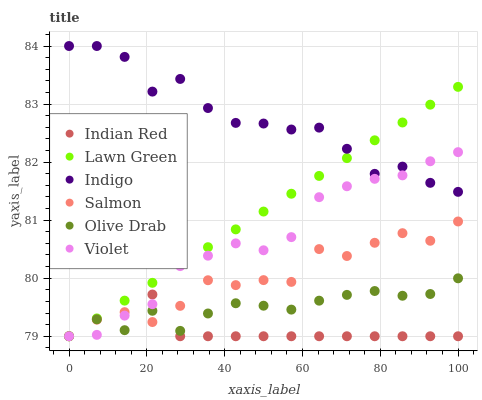Does Indian Red have the minimum area under the curve?
Answer yes or no. Yes. Does Indigo have the maximum area under the curve?
Answer yes or no. Yes. Does Salmon have the minimum area under the curve?
Answer yes or no. No. Does Salmon have the maximum area under the curve?
Answer yes or no. No. Is Lawn Green the smoothest?
Answer yes or no. Yes. Is Indigo the roughest?
Answer yes or no. Yes. Is Salmon the smoothest?
Answer yes or no. No. Is Salmon the roughest?
Answer yes or no. No. Does Lawn Green have the lowest value?
Answer yes or no. Yes. Does Indigo have the lowest value?
Answer yes or no. No. Does Indigo have the highest value?
Answer yes or no. Yes. Does Salmon have the highest value?
Answer yes or no. No. Is Olive Drab less than Indigo?
Answer yes or no. Yes. Is Indigo greater than Salmon?
Answer yes or no. Yes. Does Salmon intersect Indian Red?
Answer yes or no. Yes. Is Salmon less than Indian Red?
Answer yes or no. No. Is Salmon greater than Indian Red?
Answer yes or no. No. Does Olive Drab intersect Indigo?
Answer yes or no. No. 